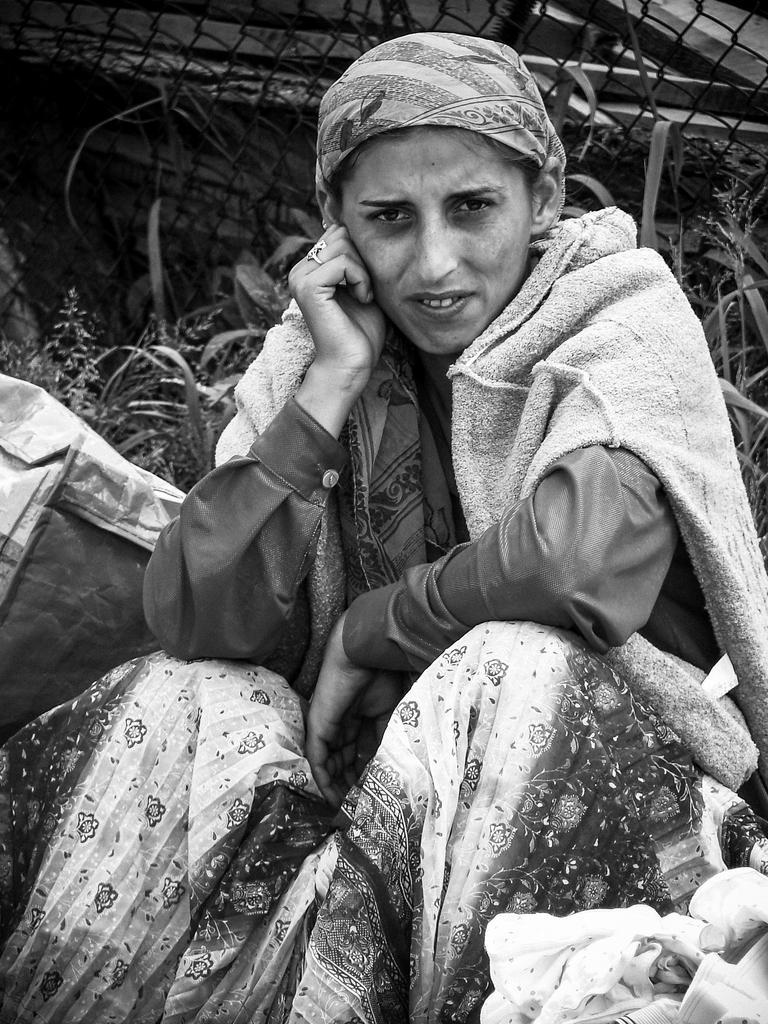What is the color scheme of the image? The image is black and white. Who or what can be seen in the image? There is a woman in the image. What type of vegetation is visible in the image? There are plants visible in the image. What material is the fencing in the image made of? The fencing in the image is made of metal. How many horses are visible in the image? There are no horses present in the image. Can you tell me the variety of tomatoes growing in the image? There are no tomatoes or tomato plants visible in the image. 